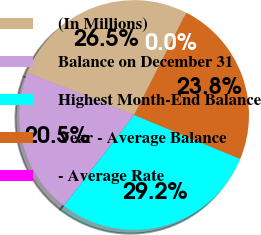Convert chart. <chart><loc_0><loc_0><loc_500><loc_500><pie_chart><fcel>(In Millions)<fcel>Balance on December 31<fcel>Highest Month-End Balance<fcel>Year - Average Balance<fcel>- Average Rate<nl><fcel>26.5%<fcel>20.52%<fcel>29.22%<fcel>23.76%<fcel>0.0%<nl></chart> 